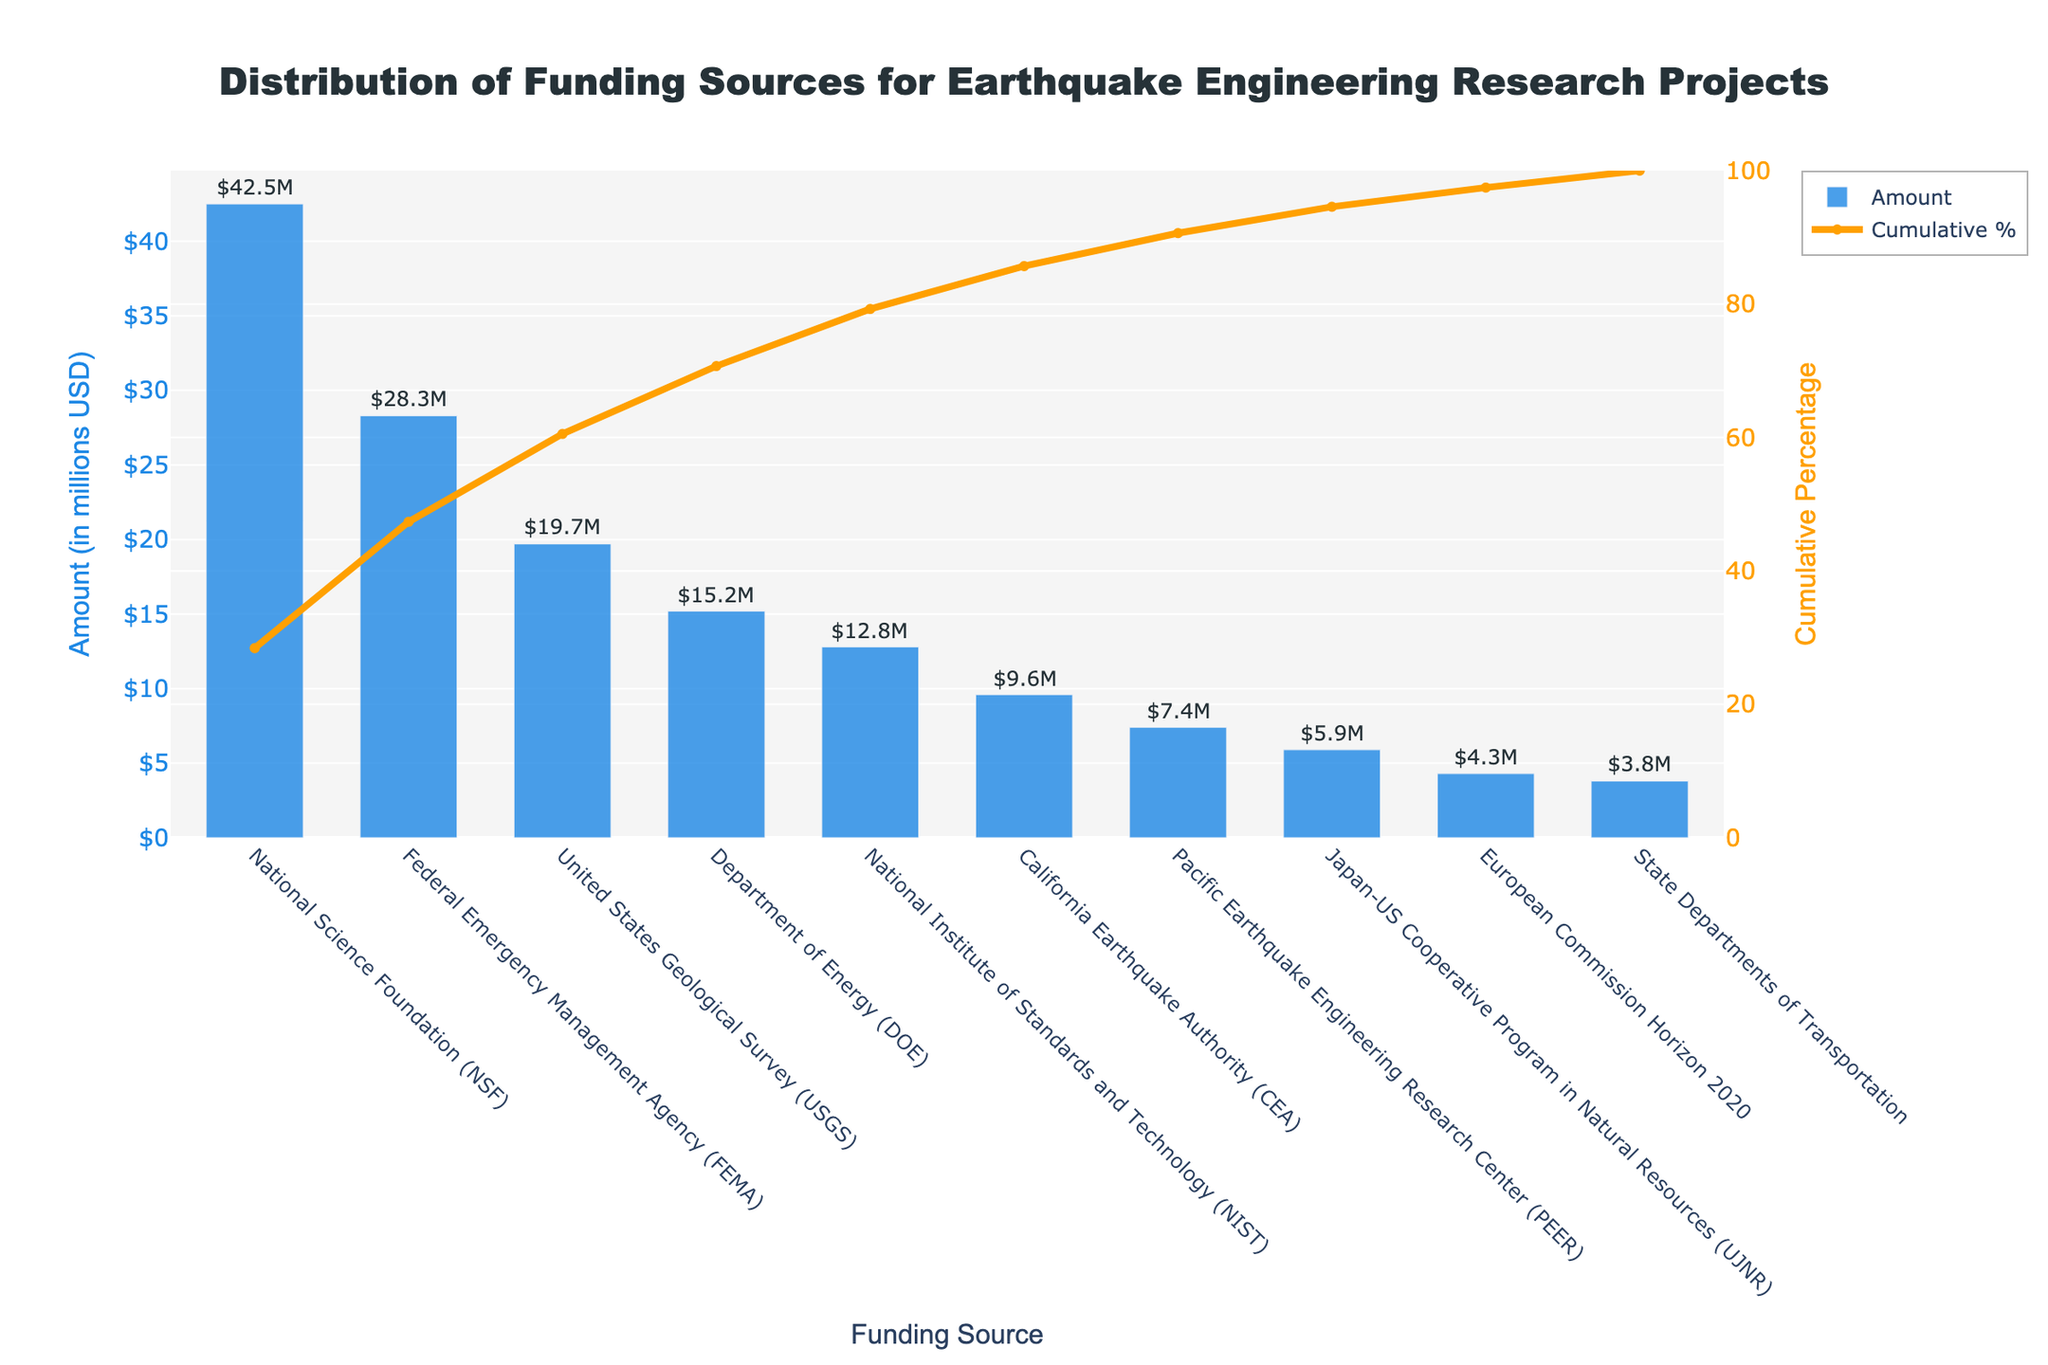What is the total amount of funding from the National Science Foundation (NSF)? The bar chart shows the amount of funding from different sources. The bar corresponding to NSF is labeled with the amount.
Answer: 42.5 million USD Which funding source contributes the least amount to earthquake engineering research projects? By examining the bar heights, the shortest bar represents the funding source with the least contribution.
Answer: State Departments of Transportation What is the cumulative percentage contribution of the top three funding sources? The cumulative percentage line graph shows the cumulative percentage when summed from the top to the third funding source on the x-axis.
Answer: 74% How many funding sources contribute more than 10 million USD each? By examining the bar heights and the annotated numbers, count the bars with amounts greater than 10 million USD.
Answer: 5 What is the difference in funding amounts between the highest and the lowest funding sources? Subtract the amount for the lowest funding source from the amount for the highest. NSF (42.5) - State Departments of Transportation (3.8).
Answer: 38.7 million USD Which funding sources together contribute to over 50% of the total funding? Analyze the cumulative percentage line to identify the funding sources until the cumulative percentage exceeds 50%.
Answer: NSF and FEMA What is the cumulative percentage after including the funding from DOE? Follow the cumulative percentage line and look at the value corresponding to the DOE bar.
Answer: 78.7% Compare the funding amounts from USGS and NIST. Which one is higher and by how much? Examine the heights of the bars and the annotated amounts. Subtract NIST's amount from USGS's amount. USGS (19.7) - NIST (12.8).
Answer: USGS by 6.9 million USD What is the title of the graph? The graph's title is displayed at the top.
Answer: Distribution of Funding Sources for Earthquake Engineering Research Projects At what cumulative percentage is the total contribution from NSF, FEMA, and USGS? Add the individual percentages for NSF, FEMA, and USGS from the cumulative line.
Answer: 74% 